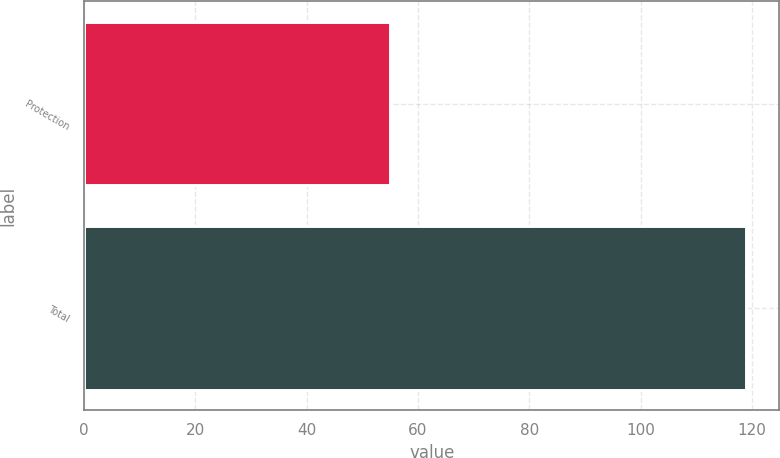Convert chart to OTSL. <chart><loc_0><loc_0><loc_500><loc_500><bar_chart><fcel>Protection<fcel>Total<nl><fcel>55<fcel>119<nl></chart> 